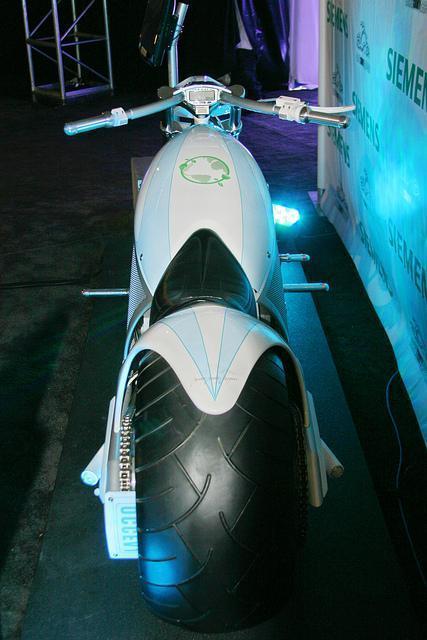How many tires are on this vehicle?
Give a very brief answer. 2. 